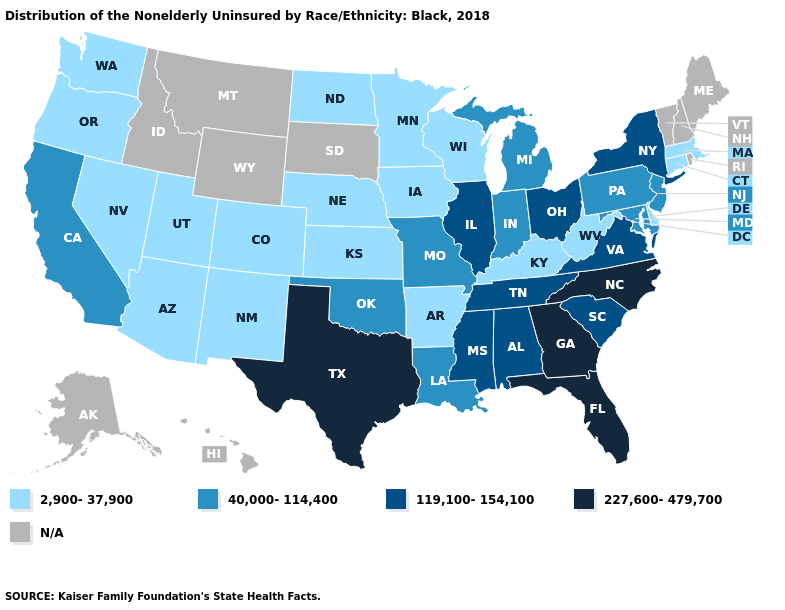Name the states that have a value in the range N/A?
Answer briefly. Alaska, Hawaii, Idaho, Maine, Montana, New Hampshire, Rhode Island, South Dakota, Vermont, Wyoming. Which states hav the highest value in the South?
Keep it brief. Florida, Georgia, North Carolina, Texas. Which states have the lowest value in the South?
Keep it brief. Arkansas, Delaware, Kentucky, West Virginia. Among the states that border Wyoming , which have the highest value?
Answer briefly. Colorado, Nebraska, Utah. What is the highest value in states that border North Dakota?
Concise answer only. 2,900-37,900. Name the states that have a value in the range 227,600-479,700?
Be succinct. Florida, Georgia, North Carolina, Texas. What is the value of Missouri?
Give a very brief answer. 40,000-114,400. Which states have the lowest value in the MidWest?
Be succinct. Iowa, Kansas, Minnesota, Nebraska, North Dakota, Wisconsin. Among the states that border Indiana , does Michigan have the highest value?
Give a very brief answer. No. Name the states that have a value in the range 40,000-114,400?
Quick response, please. California, Indiana, Louisiana, Maryland, Michigan, Missouri, New Jersey, Oklahoma, Pennsylvania. Name the states that have a value in the range 119,100-154,100?
Keep it brief. Alabama, Illinois, Mississippi, New York, Ohio, South Carolina, Tennessee, Virginia. What is the value of Idaho?
Concise answer only. N/A. Which states have the highest value in the USA?
Answer briefly. Florida, Georgia, North Carolina, Texas. Name the states that have a value in the range 40,000-114,400?
Be succinct. California, Indiana, Louisiana, Maryland, Michigan, Missouri, New Jersey, Oklahoma, Pennsylvania. 